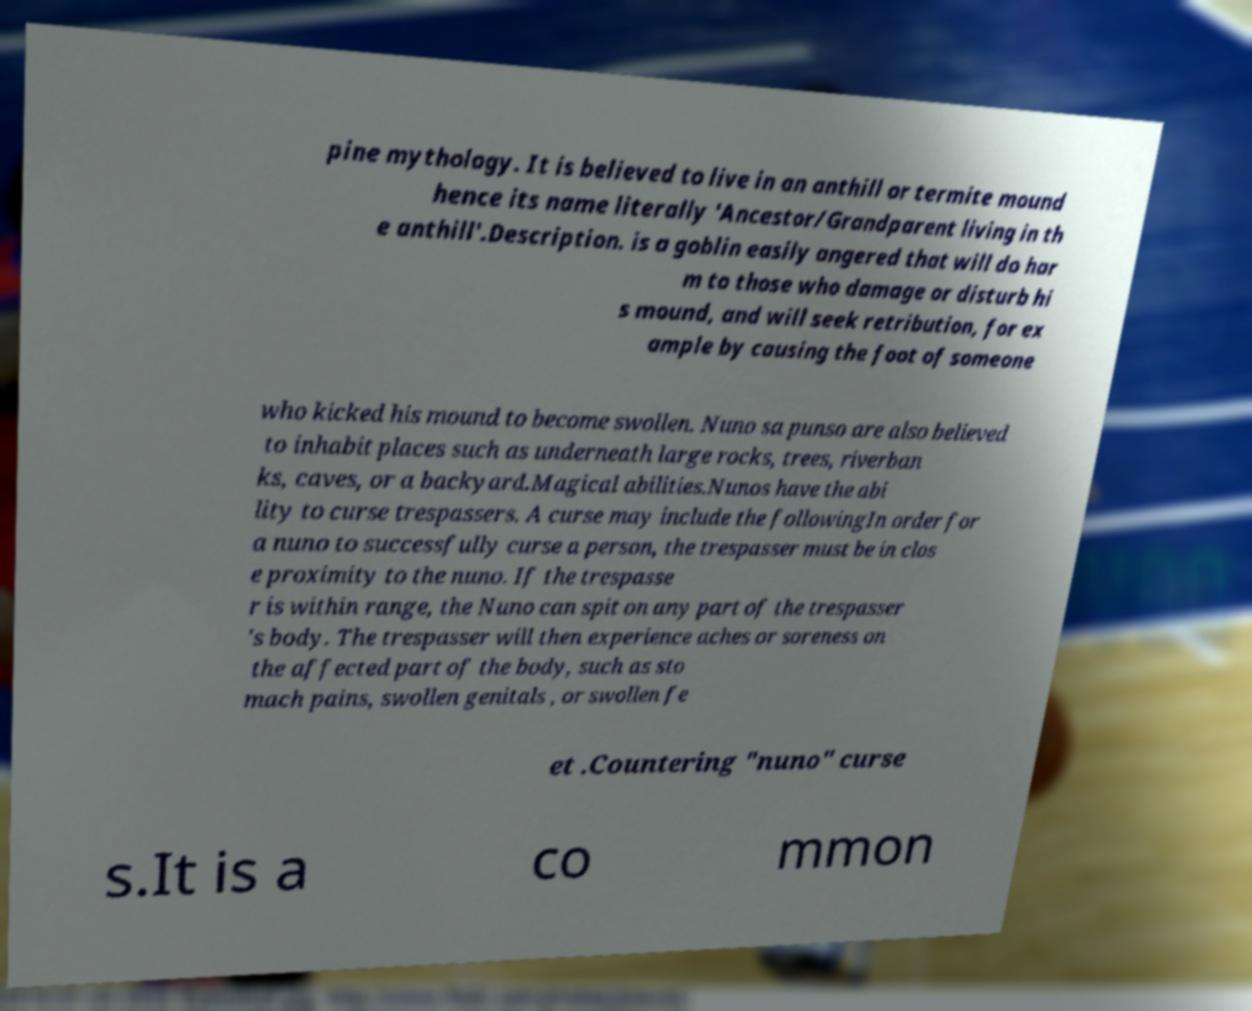I need the written content from this picture converted into text. Can you do that? pine mythology. It is believed to live in an anthill or termite mound hence its name literally 'Ancestor/Grandparent living in th e anthill'.Description. is a goblin easily angered that will do har m to those who damage or disturb hi s mound, and will seek retribution, for ex ample by causing the foot of someone who kicked his mound to become swollen. Nuno sa punso are also believed to inhabit places such as underneath large rocks, trees, riverban ks, caves, or a backyard.Magical abilities.Nunos have the abi lity to curse trespassers. A curse may include the followingIn order for a nuno to successfully curse a person, the trespasser must be in clos e proximity to the nuno. If the trespasse r is within range, the Nuno can spit on any part of the trespasser 's body. The trespasser will then experience aches or soreness on the affected part of the body, such as sto mach pains, swollen genitals , or swollen fe et .Countering "nuno" curse s.It is a co mmon 